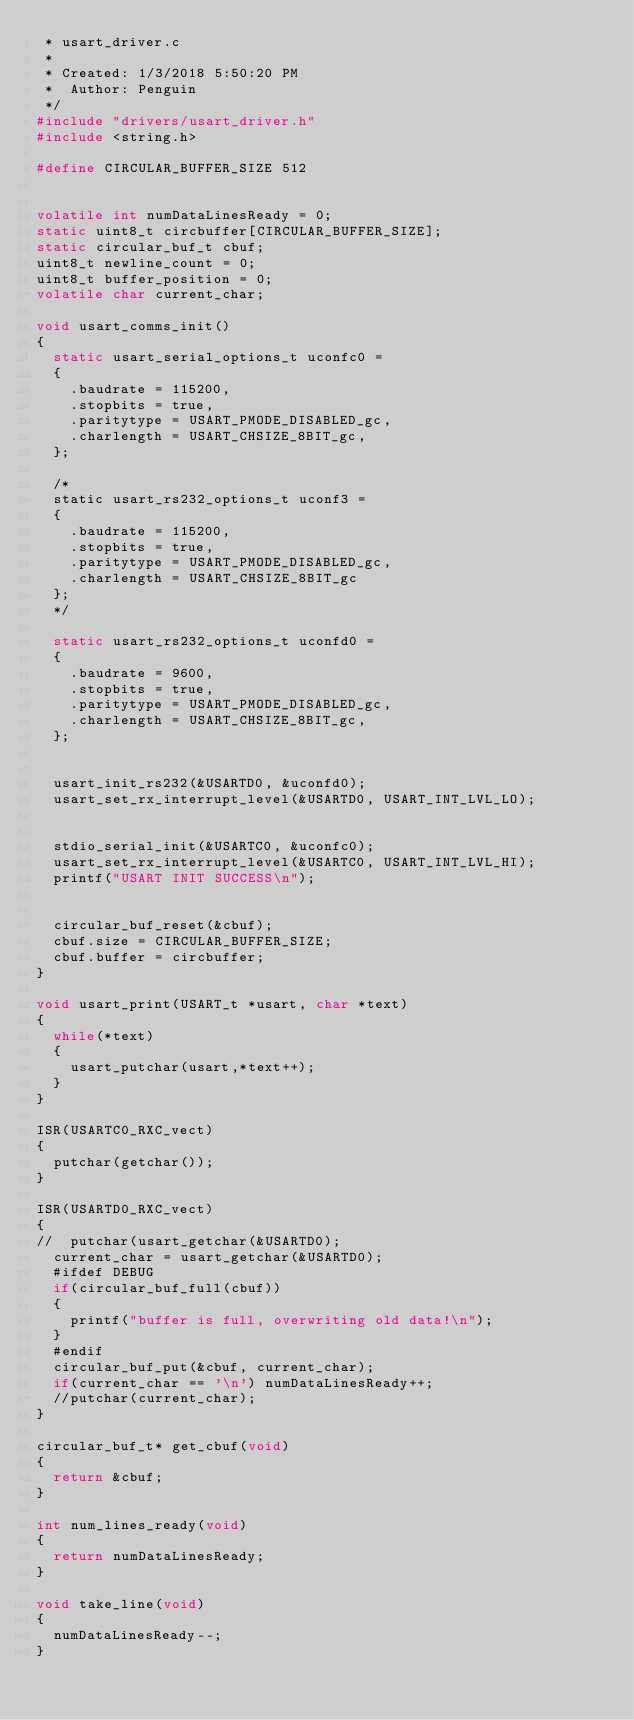<code> <loc_0><loc_0><loc_500><loc_500><_C_> * usart_driver.c
 *
 * Created: 1/3/2018 5:50:20 PM
 *  Author: Penguin
 */ 
#include "drivers/usart_driver.h"
#include <string.h>

#define CIRCULAR_BUFFER_SIZE 512


volatile int numDataLinesReady = 0;
static uint8_t circbuffer[CIRCULAR_BUFFER_SIZE];
static circular_buf_t cbuf;
uint8_t newline_count = 0;
uint8_t buffer_position = 0;
volatile char current_char;

void usart_comms_init()
{
	static usart_serial_options_t uconfc0 =
	{
		.baudrate = 115200,
		.stopbits = true,
		.paritytype = USART_PMODE_DISABLED_gc,
		.charlength = USART_CHSIZE_8BIT_gc,
	};
	
	/*
	static usart_rs232_options_t uconf3 =
	{
		.baudrate = 115200,
		.stopbits = true,
		.paritytype = USART_PMODE_DISABLED_gc,
		.charlength = USART_CHSIZE_8BIT_gc
	};
	*/
	
	static usart_rs232_options_t uconfd0 =
	{
		.baudrate = 9600,
		.stopbits = true,
		.paritytype = USART_PMODE_DISABLED_gc,
		.charlength = USART_CHSIZE_8BIT_gc,
	};


	usart_init_rs232(&USARTD0, &uconfd0);
	usart_set_rx_interrupt_level(&USARTD0, USART_INT_LVL_LO);
	
	
	stdio_serial_init(&USARTC0, &uconfc0);
	usart_set_rx_interrupt_level(&USARTC0, USART_INT_LVL_HI);
	printf("USART INIT SUCCESS\n");
	
	
	circular_buf_reset(&cbuf);
	cbuf.size = CIRCULAR_BUFFER_SIZE;
	cbuf.buffer = circbuffer;
}

void usart_print(USART_t *usart, char *text)
{
	while(*text)
	{
		usart_putchar(usart,*text++);
	}
}

ISR(USARTC0_RXC_vect)
{	
	putchar(getchar());
}

ISR(USARTD0_RXC_vect)
{
// 	putchar(usart_getchar(&USARTD0);
	current_char = usart_getchar(&USARTD0);
	#ifdef DEBUG
	if(circular_buf_full(cbuf))
	{
		printf("buffer is full, overwriting old data!\n");
	}
	#endif
	circular_buf_put(&cbuf, current_char);
	if(current_char == '\n') numDataLinesReady++;
	//putchar(current_char);
}

circular_buf_t* get_cbuf(void)
{
	return &cbuf;
}

int num_lines_ready(void)
{
	return numDataLinesReady;
}

void take_line(void)
{
	numDataLinesReady--;
}</code> 